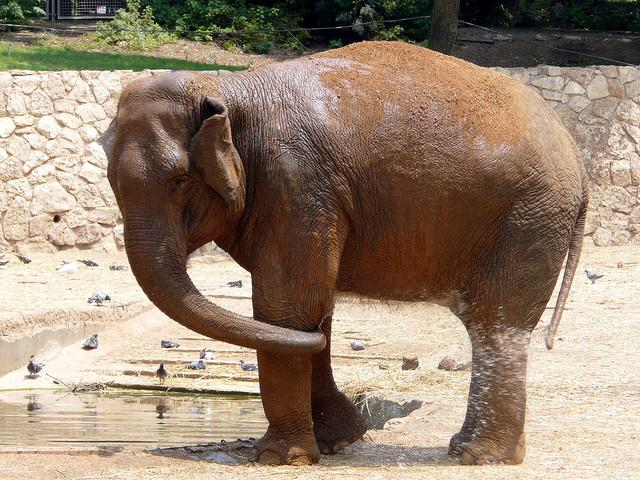Why do hunters hunt this animal? Please explain your reasoning. ivory tusks. The animal usually grows white tusks. 